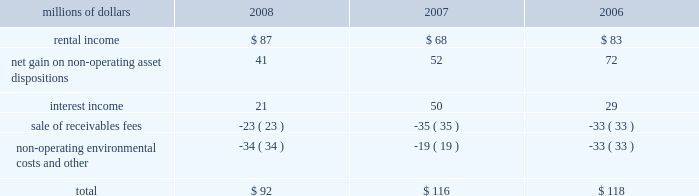The pension plan investments are held in a master trust , with the northern trust company .
Investments in the master trust are valued at fair value , which has been determined based on fair value of the underlying investments of the master trust .
Investments in securities traded on public security exchanges are valued at their closing market prices on the valuation date ; where no sale was made on the valuation date , the security is generally valued at its most recent bid price .
Certain short-term investments are carried at cost , which approximates fair value .
Investments in registered investment companies and common trust funds , which primarily invest in stocks , bonds , and commodity futures , are valued using publicly available market prices for the underlying investments held by these entities .
The majority of pension plan assets are invested in equity securities , because equity portfolios have historically provided higher returns than debt and other asset classes over extended time horizons , and are expected to do so in the future .
Correspondingly , equity investments also entail greater risks than other investments .
Equity risks are balanced by investing a significant portion of the plan 2019s assets in high quality debt securities .
The average quality rating of the debt portfolio exceeded aa as of december 31 , 2008 and 2007 .
The debt portfolio is also broadly diversified and invested primarily in u.s .
Treasury , mortgage , and corporate securities with an intermediate average maturity .
The weighted-average maturity of the debt portfolio was 5 years at both december 31 , 2008 and 2007 , respectively .
The investment of pension plan assets in securities issued by union pacific is specifically prohibited for both the equity and debt portfolios , other than through index fund holdings .
Other retirement programs thrift plan 2013 we provide a defined contribution plan ( thrift plan ) to eligible non-union employees and make matching contributions to the thrift plan .
We match 50 cents for each dollar contributed by employees up to the first six percent of compensation contributed .
Our thrift plan contributions were $ 14 million in 2008 , $ 14 million in 2007 , and $ 13 million in 2006 .
Railroad retirement system 2013 all railroad employees are covered by the railroad retirement system ( the system ) .
Contributions made to the system are expensed as incurred and amounted to approximately $ 620 million in 2008 , $ 616 million in 2007 , and $ 615 million in 2006 .
Collective bargaining agreements 2013 under collective bargaining agreements , we provide certain postretirement healthcare and life insurance benefits for eligible union employees .
Premiums under the plans are expensed as incurred and amounted to $ 49 million in 2008 and $ 40 million in both 2007 and 5 .
Other income other income included the following for the years ended december 31 : millions of dollars 2008 2007 2006 .

What was the percentage change in rental income from 2006 to 2007? 
Computations: ((68 - 83) / 83)
Answer: -0.18072. 